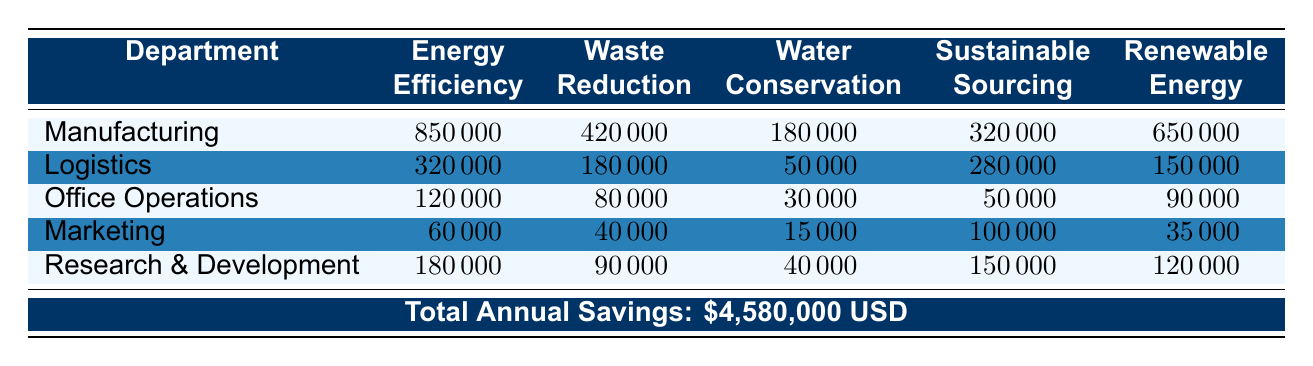What department achieves the highest cost savings from Energy Efficiency? By examining the "Energy Efficiency" column in the table, it is clear that the Manufacturing department has the highest value of 850,000.
Answer: Manufacturing What is the total cost savings for the Logistics department from all sustainable practices? To find the total cost savings for Logistics, sum all values in the Logistics row: 320,000 + 180,000 + 50,000 + 280,000 + 150,000 = 980,000.
Answer: 980,000 Is the total annual savings across all departments greater than 4 million? The table indicates that total annual savings is 4,580,000, which is indeed greater than 4 million.
Answer: Yes What is the difference in cost savings from Waste Reduction between Manufacturing and Office Operations? The value for Manufacturing under Waste Reduction is 420,000, while for Office Operations, it is 80,000. The difference is 420,000 - 80,000 = 340,000.
Answer: 340,000 Which department has the lowest cost savings in Water Conservation? Looking at the "Water Conservation" column, Office Operations has the lowest value at 30,000.
Answer: Office Operations What is the average cost savings from Renewable Energy across all departments? To calculate the average, first sum the Renewable Energy values: 650,000 + 150,000 + 90,000 + 35,000 + 120,000 = 1,045,000. Then divide this sum by the number of departments (5): 1,045,000 / 5 = 209,000.
Answer: 209,000 Does the Marketing department make more cost savings from Sustainable Sourcing than from Waste Reduction? Marketing has cost savings of 100,000 from Sustainable Sourcing and 40,000 from Waste Reduction. Since 100,000 is greater than 40,000, the statement is true.
Answer: Yes What is the combined cost savings from Waste Reduction and Water Conservation in the Research & Development department? For Research & Development, the savings for Waste Reduction is 90,000 and for Water Conservation, it is 40,000. Combined, this equals 90,000 + 40,000 = 130,000.
Answer: 130,000 